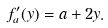Convert formula to latex. <formula><loc_0><loc_0><loc_500><loc_500>f _ { a } ^ { \prime } ( y ) = a + 2 y .</formula> 